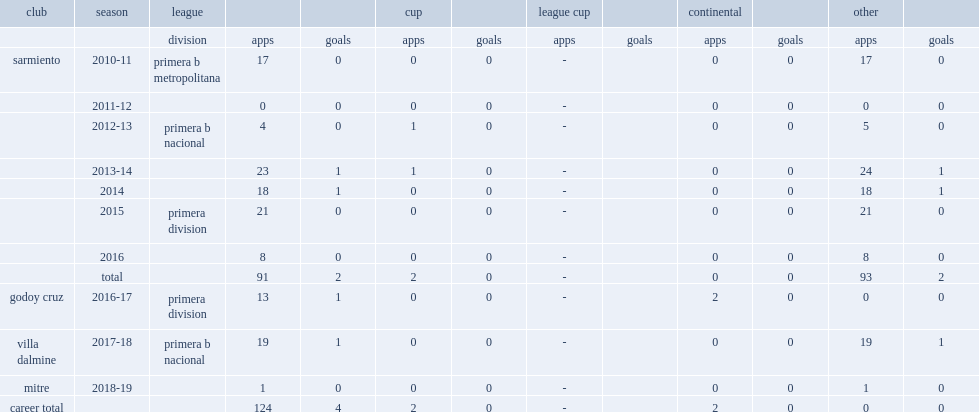How many league goals did sanchez score for sarmiento totally? 2.0. 